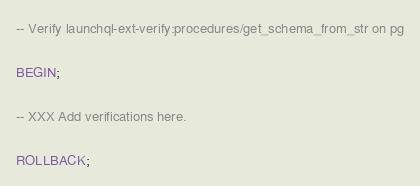<code> <loc_0><loc_0><loc_500><loc_500><_SQL_>-- Verify launchql-ext-verify:procedures/get_schema_from_str on pg

BEGIN;

-- XXX Add verifications here.

ROLLBACK;
</code> 